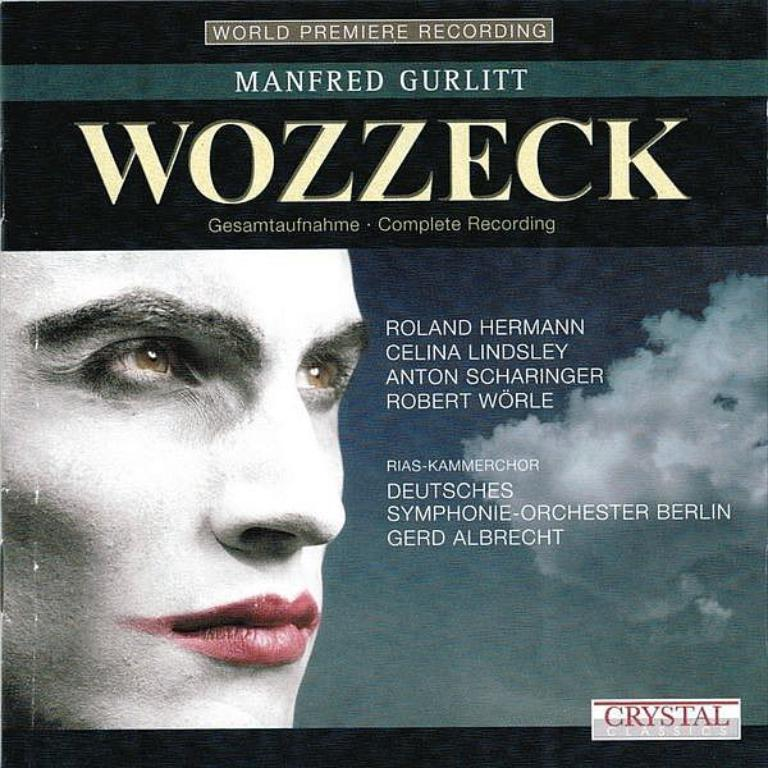What is the main subject of the image? There is a person's face in the image. What is unique about the person's face in the image? There is writing on the person's face. Can you describe the writing on the person's face? The writing is in different colors. What colors can be seen in the background of the image? The background of the image is blue and white. How many clocks are hanging on the shelf behind the person's face in the image? There are no clocks or shelves present in the image; it only features a person's face with writing on it and a blue and white background. 